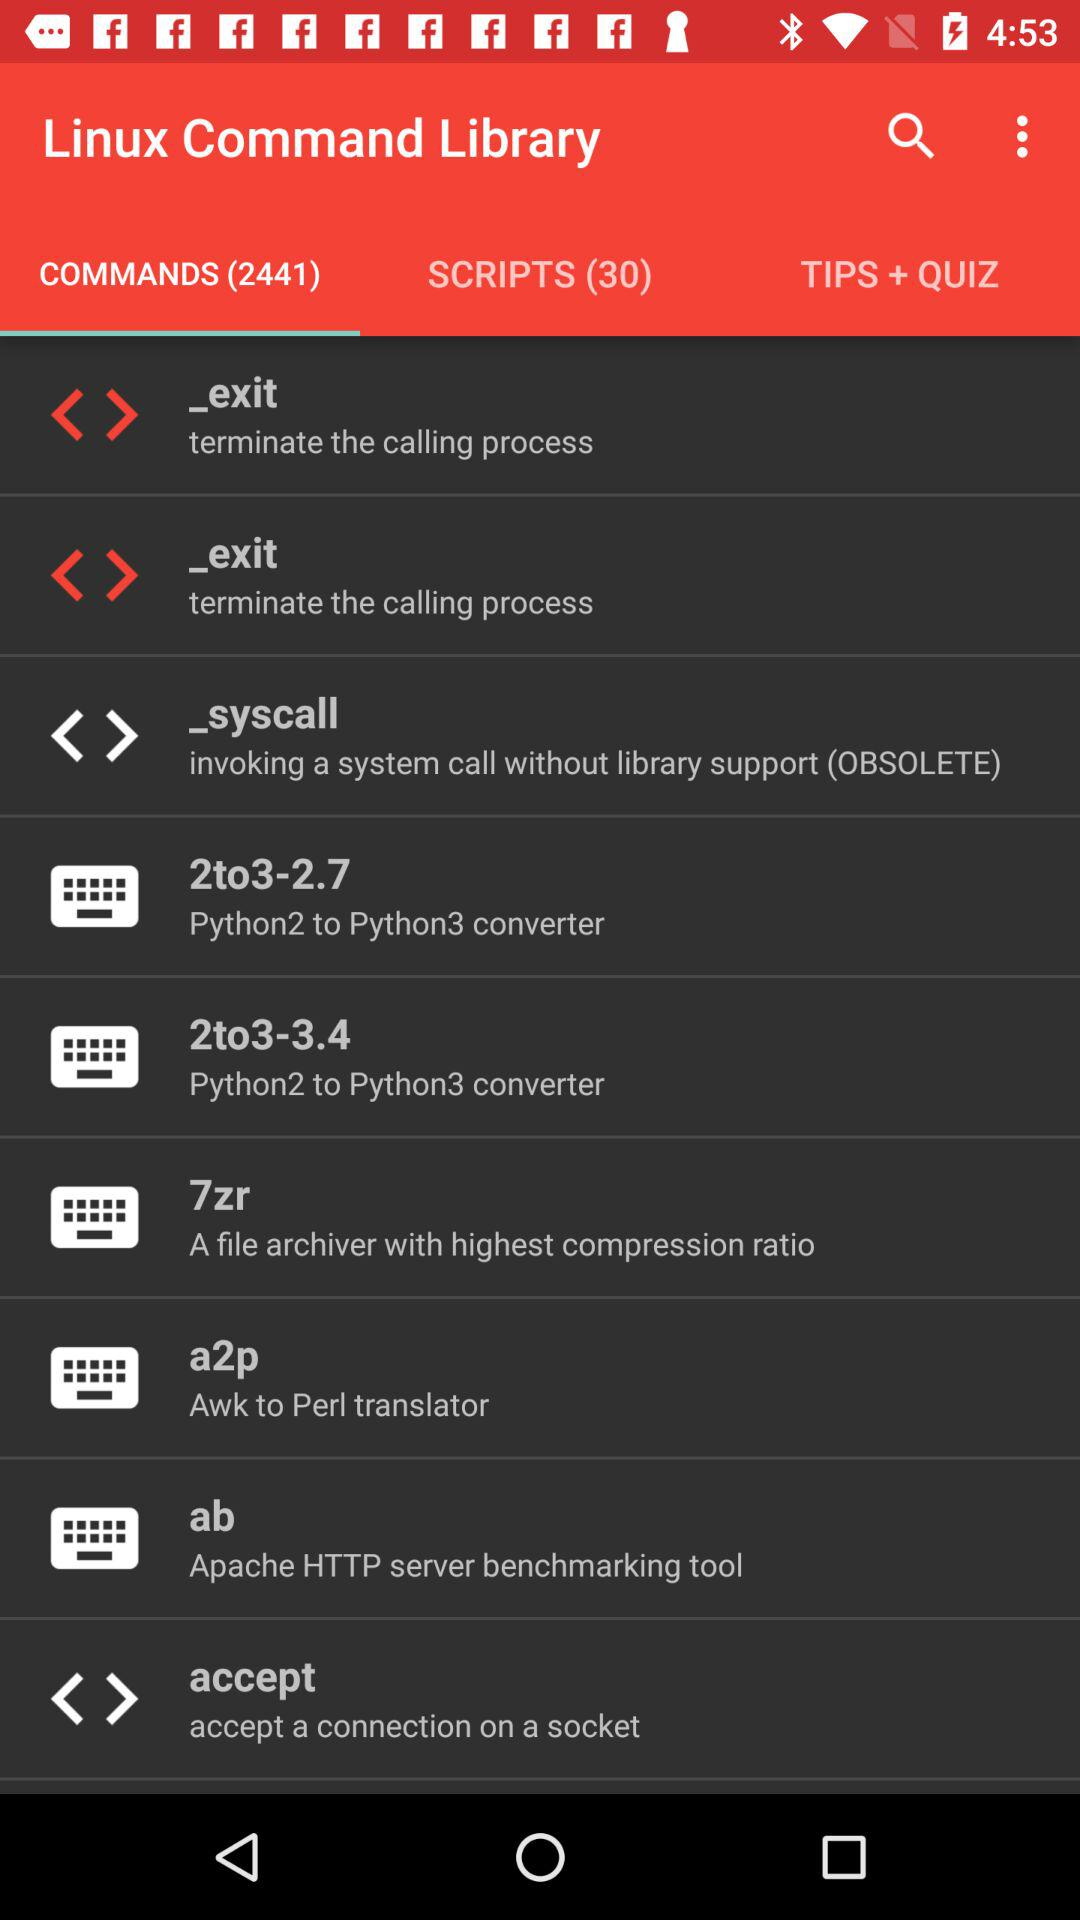How many "SCRIPTS" are there in the "Linux Command Library"? There are 30 "SCRIPTS" in the "Linux Command Library". 